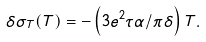Convert formula to latex. <formula><loc_0><loc_0><loc_500><loc_500>\delta \sigma _ { T } ( T ) = - \left ( 3 e ^ { 2 } \tau \alpha / \pi \delta \right ) T .</formula> 